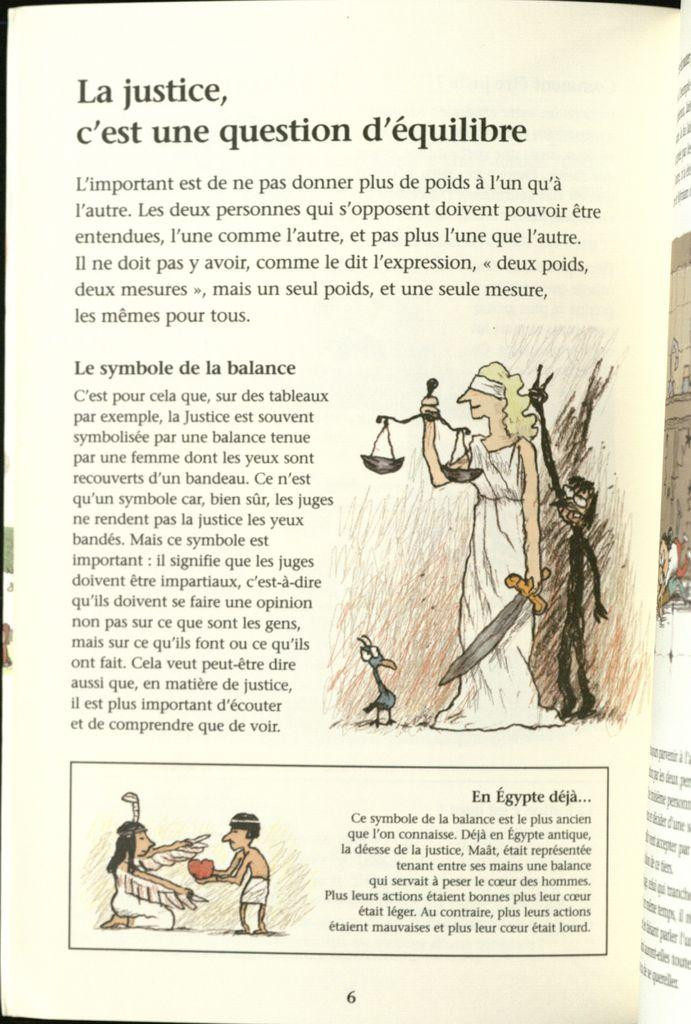What is the main object in the image? There is a paper in the image. What can be seen on the paper? The paper contains pictures of persons and text. What is the person on the right side of the image holding? The person is holding a sword and a balance. How does the chin of the person on the left side of the image compare to the chin of the person on the right side of the image? There is no chin visible in the image, as the focus is on the paper and the person holding a sword and a balance. 